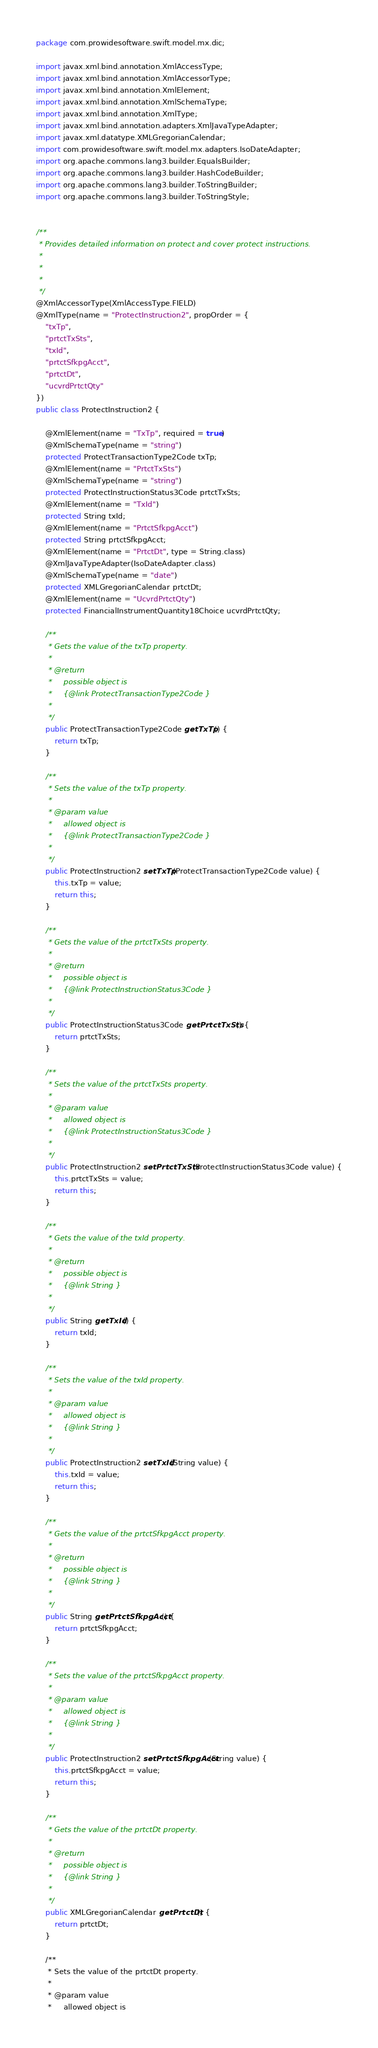Convert code to text. <code><loc_0><loc_0><loc_500><loc_500><_Java_>
package com.prowidesoftware.swift.model.mx.dic;

import javax.xml.bind.annotation.XmlAccessType;
import javax.xml.bind.annotation.XmlAccessorType;
import javax.xml.bind.annotation.XmlElement;
import javax.xml.bind.annotation.XmlSchemaType;
import javax.xml.bind.annotation.XmlType;
import javax.xml.bind.annotation.adapters.XmlJavaTypeAdapter;
import javax.xml.datatype.XMLGregorianCalendar;
import com.prowidesoftware.swift.model.mx.adapters.IsoDateAdapter;
import org.apache.commons.lang3.builder.EqualsBuilder;
import org.apache.commons.lang3.builder.HashCodeBuilder;
import org.apache.commons.lang3.builder.ToStringBuilder;
import org.apache.commons.lang3.builder.ToStringStyle;


/**
 * Provides detailed information on protect and cover protect instructions.
 * 
 * 
 * 
 */
@XmlAccessorType(XmlAccessType.FIELD)
@XmlType(name = "ProtectInstruction2", propOrder = {
    "txTp",
    "prtctTxSts",
    "txId",
    "prtctSfkpgAcct",
    "prtctDt",
    "ucvrdPrtctQty"
})
public class ProtectInstruction2 {

    @XmlElement(name = "TxTp", required = true)
    @XmlSchemaType(name = "string")
    protected ProtectTransactionType2Code txTp;
    @XmlElement(name = "PrtctTxSts")
    @XmlSchemaType(name = "string")
    protected ProtectInstructionStatus3Code prtctTxSts;
    @XmlElement(name = "TxId")
    protected String txId;
    @XmlElement(name = "PrtctSfkpgAcct")
    protected String prtctSfkpgAcct;
    @XmlElement(name = "PrtctDt", type = String.class)
    @XmlJavaTypeAdapter(IsoDateAdapter.class)
    @XmlSchemaType(name = "date")
    protected XMLGregorianCalendar prtctDt;
    @XmlElement(name = "UcvrdPrtctQty")
    protected FinancialInstrumentQuantity18Choice ucvrdPrtctQty;

    /**
     * Gets the value of the txTp property.
     * 
     * @return
     *     possible object is
     *     {@link ProtectTransactionType2Code }
     *     
     */
    public ProtectTransactionType2Code getTxTp() {
        return txTp;
    }

    /**
     * Sets the value of the txTp property.
     * 
     * @param value
     *     allowed object is
     *     {@link ProtectTransactionType2Code }
     *     
     */
    public ProtectInstruction2 setTxTp(ProtectTransactionType2Code value) {
        this.txTp = value;
        return this;
    }

    /**
     * Gets the value of the prtctTxSts property.
     * 
     * @return
     *     possible object is
     *     {@link ProtectInstructionStatus3Code }
     *     
     */
    public ProtectInstructionStatus3Code getPrtctTxSts() {
        return prtctTxSts;
    }

    /**
     * Sets the value of the prtctTxSts property.
     * 
     * @param value
     *     allowed object is
     *     {@link ProtectInstructionStatus3Code }
     *     
     */
    public ProtectInstruction2 setPrtctTxSts(ProtectInstructionStatus3Code value) {
        this.prtctTxSts = value;
        return this;
    }

    /**
     * Gets the value of the txId property.
     * 
     * @return
     *     possible object is
     *     {@link String }
     *     
     */
    public String getTxId() {
        return txId;
    }

    /**
     * Sets the value of the txId property.
     * 
     * @param value
     *     allowed object is
     *     {@link String }
     *     
     */
    public ProtectInstruction2 setTxId(String value) {
        this.txId = value;
        return this;
    }

    /**
     * Gets the value of the prtctSfkpgAcct property.
     * 
     * @return
     *     possible object is
     *     {@link String }
     *     
     */
    public String getPrtctSfkpgAcct() {
        return prtctSfkpgAcct;
    }

    /**
     * Sets the value of the prtctSfkpgAcct property.
     * 
     * @param value
     *     allowed object is
     *     {@link String }
     *     
     */
    public ProtectInstruction2 setPrtctSfkpgAcct(String value) {
        this.prtctSfkpgAcct = value;
        return this;
    }

    /**
     * Gets the value of the prtctDt property.
     * 
     * @return
     *     possible object is
     *     {@link String }
     *     
     */
    public XMLGregorianCalendar getPrtctDt() {
        return prtctDt;
    }

    /**
     * Sets the value of the prtctDt property.
     * 
     * @param value
     *     allowed object is</code> 